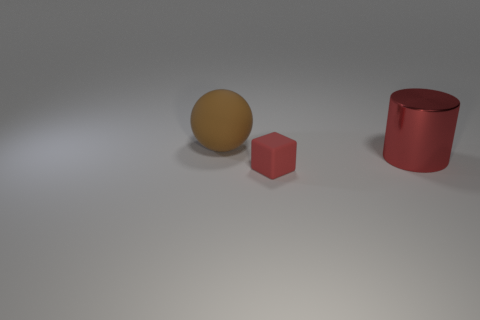Add 2 tiny matte spheres. How many objects exist? 5 Subtract all balls. How many objects are left? 2 Subtract 0 green cylinders. How many objects are left? 3 Subtract all tiny blue blocks. Subtract all red cylinders. How many objects are left? 2 Add 2 small red objects. How many small red objects are left? 3 Add 3 red matte things. How many red matte things exist? 4 